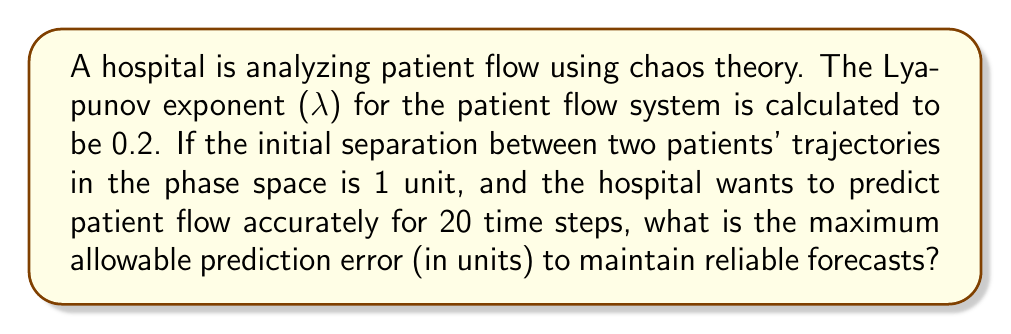Show me your answer to this math problem. To solve this problem, we'll use the concept of Lyapunov exponents from chaos theory:

1) The Lyapunov exponent (λ) measures the rate of separation of infinitesimally close trajectories. In this case, λ = 0.2.

2) The formula for the separation of trajectories over time is:

   $$d(t) = d_0 e^{\lambda t}$$

   Where:
   $d(t)$ is the separation after time $t$
   $d_0$ is the initial separation
   $e$ is Euler's number
   $λ$ is the Lyapunov exponent
   $t$ is the number of time steps

3) We're given:
   $d_0 = 1$ unit
   $λ = 0.2$
   $t = 20$ time steps

4) Plugging these values into the equation:

   $$d(20) = 1 \cdot e^{0.2 \cdot 20}$$

5) Calculating:

   $$d(20) = e^4 \approx 54.60$$

6) This means that after 20 time steps, the separation between trajectories will be about 54.60 units.

7) To maintain reliable forecasts, the maximum allowable prediction error should be less than this separation. A common practice is to use half of this value.

8) Therefore, the maximum allowable prediction error is:

   $$\text{Max Error} = \frac{54.60}{2} = 27.30$$ units
Answer: 27.30 units 